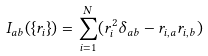Convert formula to latex. <formula><loc_0><loc_0><loc_500><loc_500>I _ { a b } ( \{ r _ { i } \} ) = \sum _ { i = 1 } ^ { N } ( r _ { i } ^ { 2 } \delta _ { a b } - r _ { i , a } r _ { i , b } )</formula> 